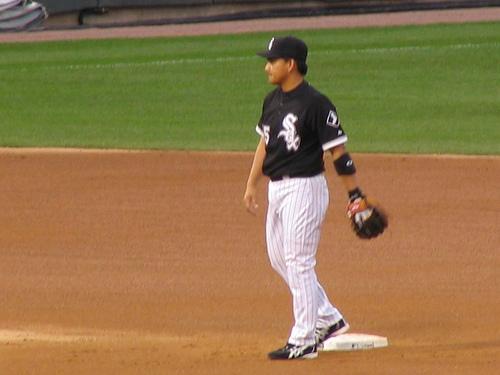Would this man wear a jock strap in his regular job?
Be succinct. Yes. What team does the man play for?
Quick response, please. White sox. Is this a professional baseball pitcher?
Be succinct. Yes. 